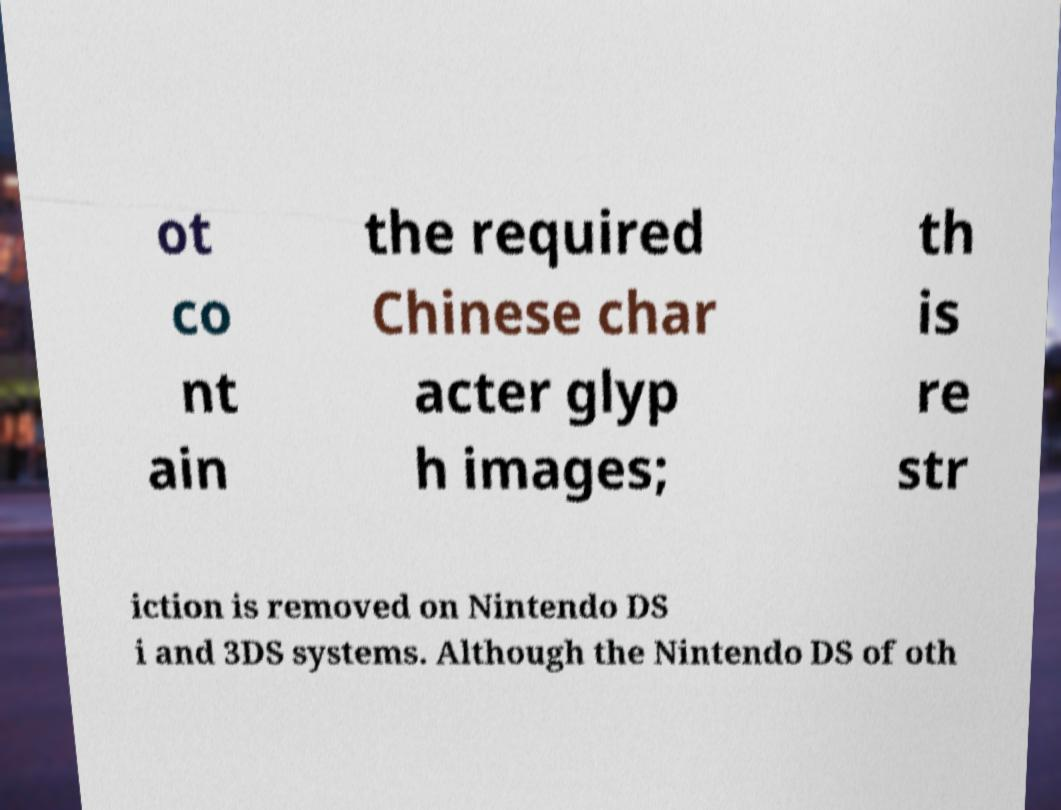Can you accurately transcribe the text from the provided image for me? ot co nt ain the required Chinese char acter glyp h images; th is re str iction is removed on Nintendo DS i and 3DS systems. Although the Nintendo DS of oth 